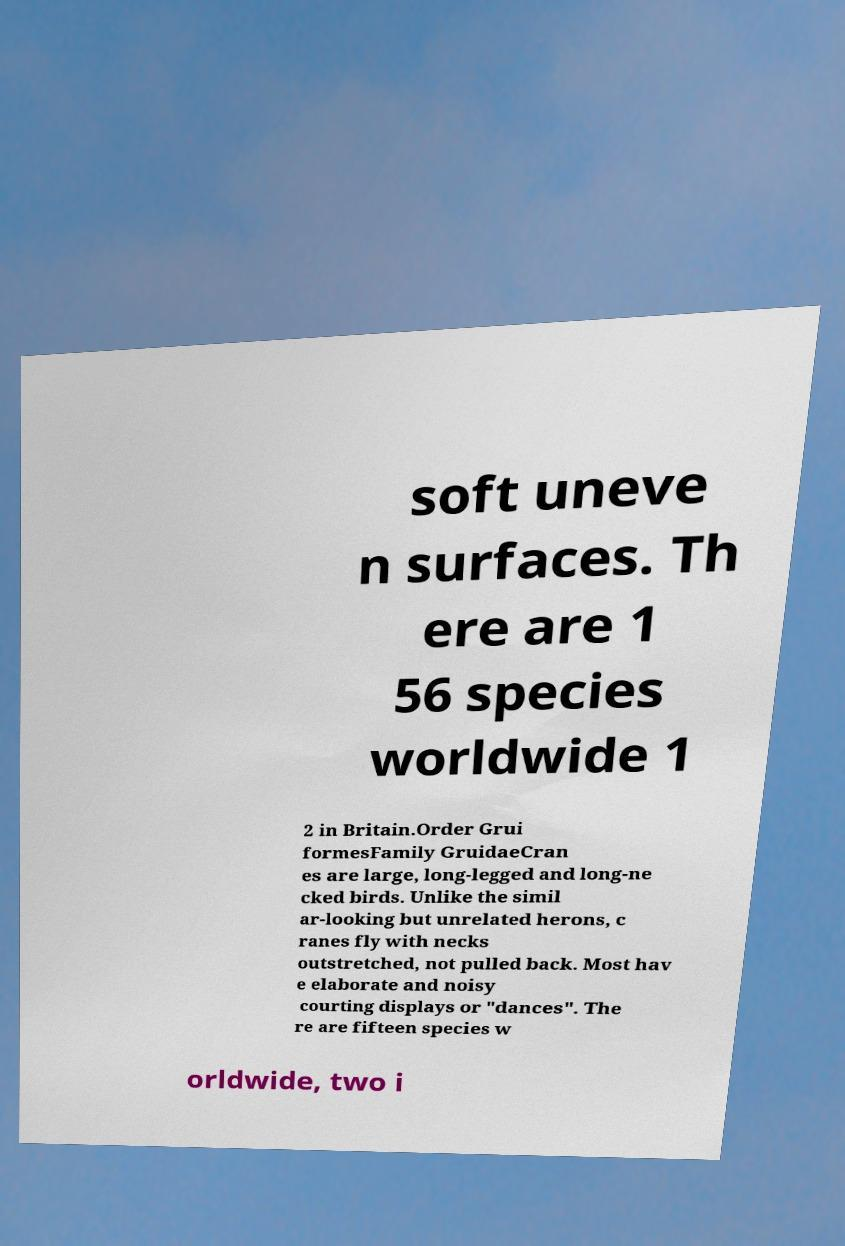Can you accurately transcribe the text from the provided image for me? soft uneve n surfaces. Th ere are 1 56 species worldwide 1 2 in Britain.Order Grui formesFamily GruidaeCran es are large, long-legged and long-ne cked birds. Unlike the simil ar-looking but unrelated herons, c ranes fly with necks outstretched, not pulled back. Most hav e elaborate and noisy courting displays or "dances". The re are fifteen species w orldwide, two i 